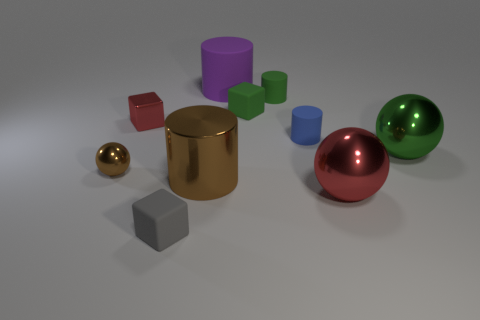Subtract all small rubber cubes. How many cubes are left? 1 Subtract all cylinders. How many objects are left? 6 Subtract 3 balls. How many balls are left? 0 Subtract all yellow balls. How many red cylinders are left? 0 Subtract all large purple cylinders. Subtract all big red matte cylinders. How many objects are left? 9 Add 4 brown cylinders. How many brown cylinders are left? 5 Add 8 blue rubber things. How many blue rubber things exist? 9 Subtract all red cubes. How many cubes are left? 2 Subtract 0 cyan blocks. How many objects are left? 10 Subtract all brown balls. Subtract all purple cubes. How many balls are left? 2 